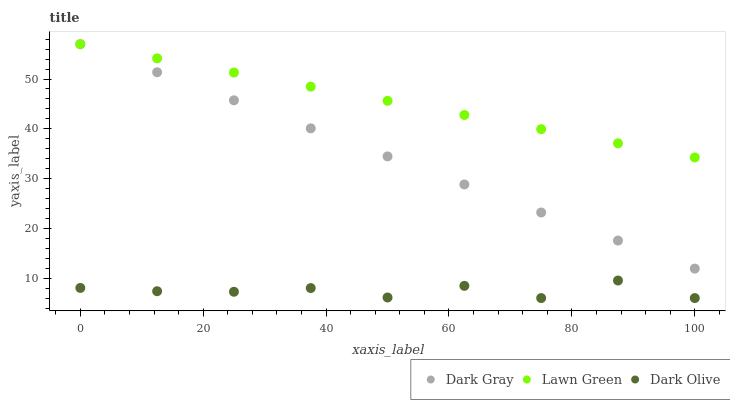Does Dark Olive have the minimum area under the curve?
Answer yes or no. Yes. Does Lawn Green have the maximum area under the curve?
Answer yes or no. Yes. Does Lawn Green have the minimum area under the curve?
Answer yes or no. No. Does Dark Olive have the maximum area under the curve?
Answer yes or no. No. Is Dark Gray the smoothest?
Answer yes or no. Yes. Is Dark Olive the roughest?
Answer yes or no. Yes. Is Lawn Green the smoothest?
Answer yes or no. No. Is Lawn Green the roughest?
Answer yes or no. No. Does Dark Olive have the lowest value?
Answer yes or no. Yes. Does Lawn Green have the lowest value?
Answer yes or no. No. Does Lawn Green have the highest value?
Answer yes or no. Yes. Does Dark Olive have the highest value?
Answer yes or no. No. Is Dark Olive less than Dark Gray?
Answer yes or no. Yes. Is Lawn Green greater than Dark Olive?
Answer yes or no. Yes. Does Lawn Green intersect Dark Gray?
Answer yes or no. Yes. Is Lawn Green less than Dark Gray?
Answer yes or no. No. Is Lawn Green greater than Dark Gray?
Answer yes or no. No. Does Dark Olive intersect Dark Gray?
Answer yes or no. No. 